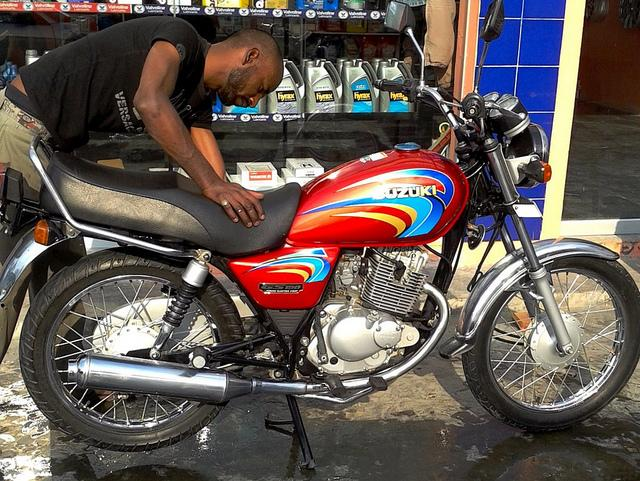What company makes the vehicle? Please explain your reasoning. suzuki. The company is suzuki. 